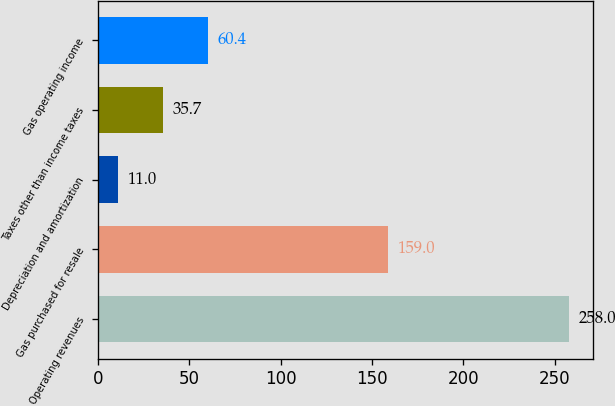Convert chart to OTSL. <chart><loc_0><loc_0><loc_500><loc_500><bar_chart><fcel>Operating revenues<fcel>Gas purchased for resale<fcel>Depreciation and amortization<fcel>Taxes other than income taxes<fcel>Gas operating income<nl><fcel>258<fcel>159<fcel>11<fcel>35.7<fcel>60.4<nl></chart> 